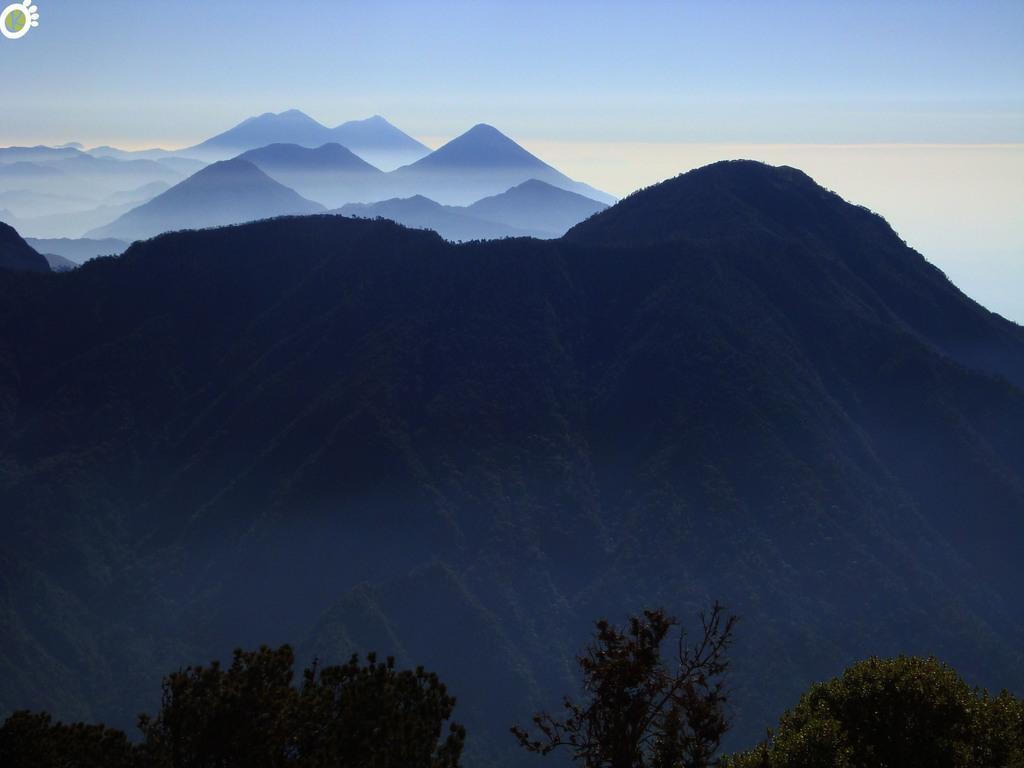What type of natural features can be seen in the image? There are trees and mountains in the image. What is visible in the background of the image? The sky is visible in the background of the image. What can be observed in the sky? Clouds are present in the sky. What type of jeans is the boat wearing in the image? There is no boat or jeans present in the image; it features trees, mountains, and a sky with clouds. 